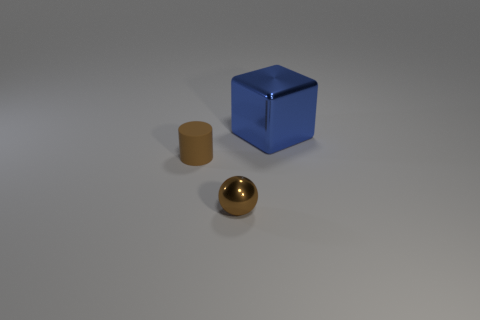The matte object that is the same size as the shiny ball is what shape?
Offer a very short reply. Cylinder. What is the material of the blue cube?
Offer a terse response. Metal. What size is the blue cube that is to the right of the brown thing that is right of the object to the left of the small brown metal object?
Give a very brief answer. Large. There is a thing that is the same color as the tiny shiny sphere; what is it made of?
Provide a short and direct response. Rubber. What number of rubber things are either yellow things or large objects?
Give a very brief answer. 0. How big is the brown matte thing?
Your response must be concise. Small. How many things are big cyan spheres or shiny objects that are in front of the blue metal thing?
Provide a succinct answer. 1. What number of other things are there of the same color as the small metallic sphere?
Your answer should be compact. 1. Is the size of the blue metal block the same as the metallic object to the left of the big blue thing?
Provide a short and direct response. No. There is a thing that is behind the brown rubber cylinder; does it have the same size as the metal sphere?
Ensure brevity in your answer.  No. 